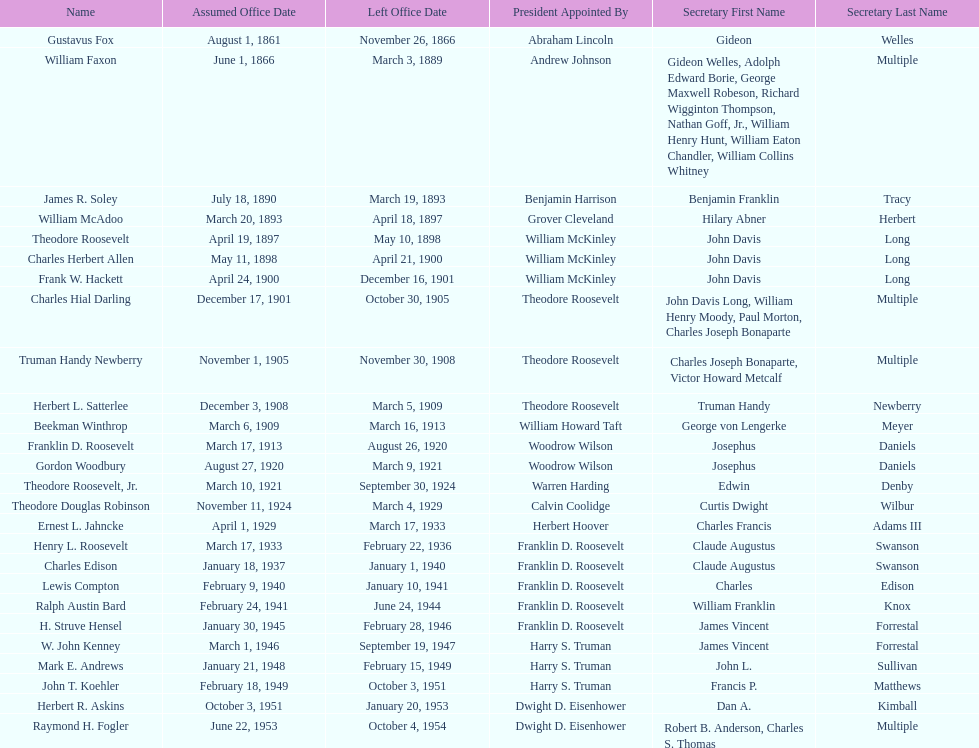Who was the first assistant secretary of the navy? Gustavus Fox. 